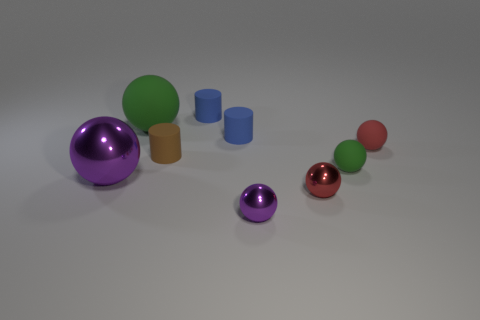There is a purple sphere to the left of the matte sphere that is on the left side of the tiny purple shiny ball; are there any purple balls behind it?
Provide a succinct answer. No. There is a big sphere behind the brown object; does it have the same color as the small rubber sphere on the left side of the small red rubber ball?
Your response must be concise. Yes. There is a purple sphere that is the same size as the red shiny object; what is its material?
Make the answer very short. Metal. What is the size of the matte sphere on the left side of the purple sphere that is on the right side of the brown rubber cylinder behind the tiny purple object?
Your answer should be very brief. Large. What number of other things are there of the same material as the tiny brown thing
Provide a succinct answer. 5. What size is the green matte object left of the brown cylinder?
Make the answer very short. Large. How many balls are behind the large shiny sphere and to the right of the small purple object?
Your response must be concise. 2. There is a tiny green thing that is behind the big sphere that is in front of the small brown rubber cylinder; what is it made of?
Offer a terse response. Rubber. There is a small green object that is the same shape as the big purple object; what material is it?
Ensure brevity in your answer.  Rubber. Are there any tiny green rubber spheres?
Your response must be concise. Yes. 